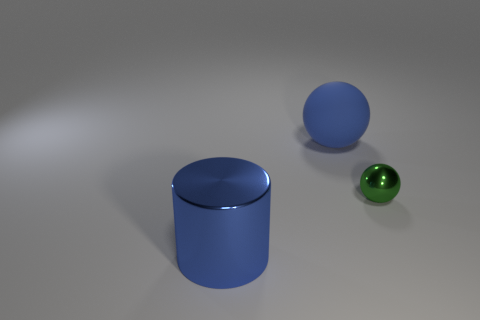There is a sphere that is in front of the large blue ball; how big is it?
Your response must be concise. Small. What material is the blue sphere?
Provide a short and direct response. Rubber. What number of things are metallic things to the left of the large blue sphere or metallic objects that are left of the small ball?
Offer a terse response. 1. What number of other things are there of the same color as the tiny metal object?
Make the answer very short. 0. There is a small green metal thing; is it the same shape as the large thing in front of the tiny metallic thing?
Give a very brief answer. No. Is the number of small shiny things that are in front of the small object less than the number of green things that are to the left of the blue ball?
Offer a very short reply. No. There is a blue object that is the same shape as the green metallic object; what is its material?
Offer a terse response. Rubber. Are there any other things that have the same material as the large cylinder?
Provide a succinct answer. Yes. Does the big shiny object have the same color as the tiny thing?
Provide a succinct answer. No. The other blue object that is the same material as the tiny object is what shape?
Your response must be concise. Cylinder. 